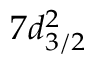Convert formula to latex. <formula><loc_0><loc_0><loc_500><loc_500>7 d _ { 3 / 2 } ^ { 2 }</formula> 